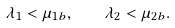Convert formula to latex. <formula><loc_0><loc_0><loc_500><loc_500>\lambda _ { 1 } < \mu _ { 1 b } , \quad \lambda _ { 2 } < \mu _ { 2 b } .</formula> 